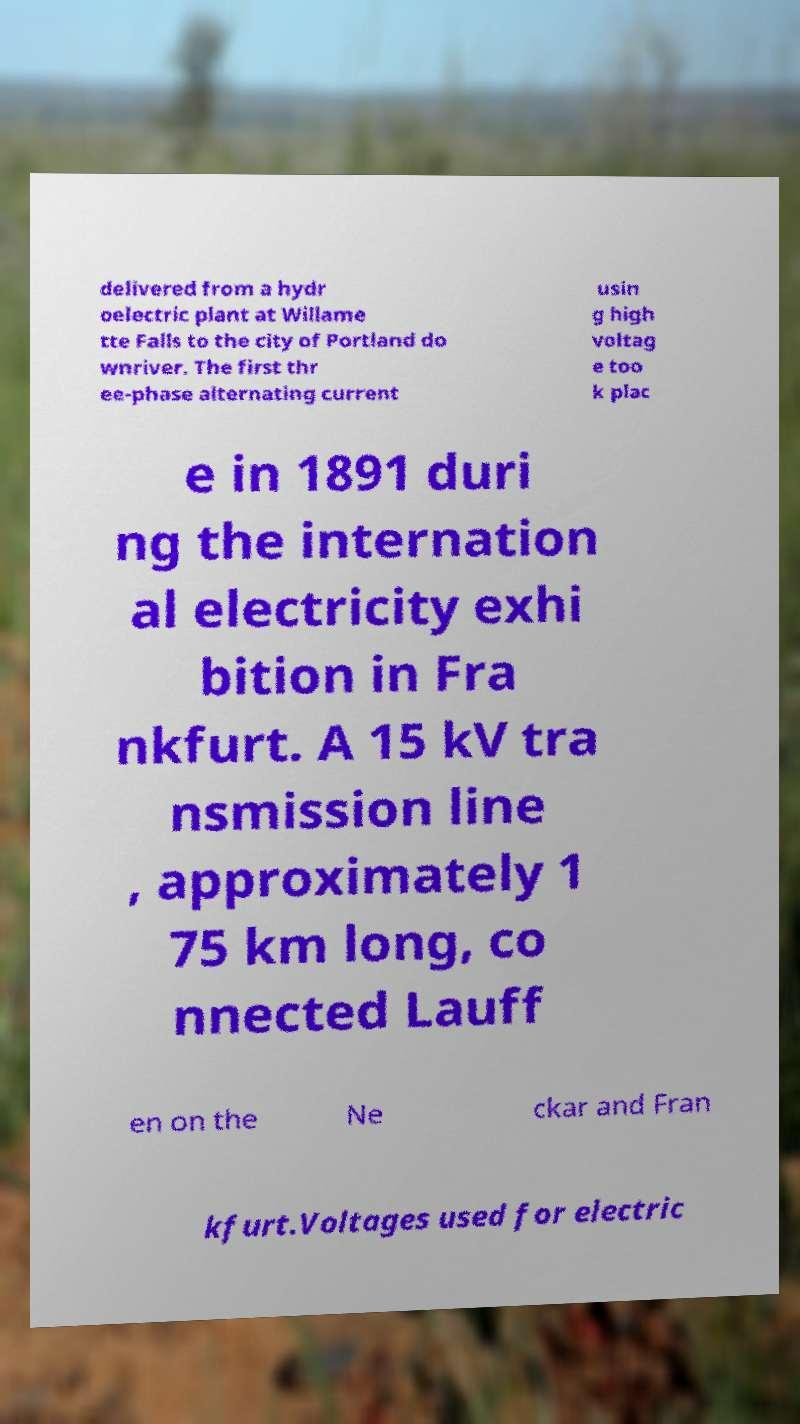I need the written content from this picture converted into text. Can you do that? delivered from a hydr oelectric plant at Willame tte Falls to the city of Portland do wnriver. The first thr ee-phase alternating current usin g high voltag e too k plac e in 1891 duri ng the internation al electricity exhi bition in Fra nkfurt. A 15 kV tra nsmission line , approximately 1 75 km long, co nnected Lauff en on the Ne ckar and Fran kfurt.Voltages used for electric 